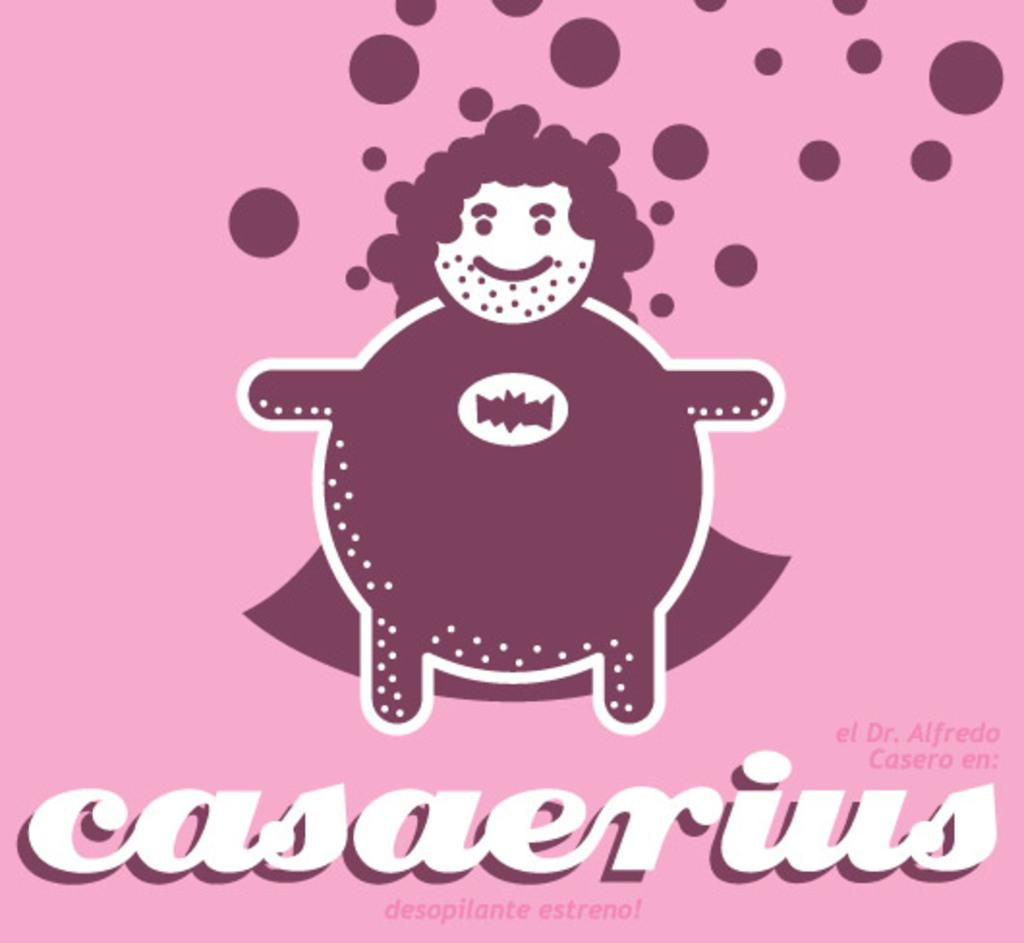<image>
Present a compact description of the photo's key features. a pink page that says 'casaerius' on it 